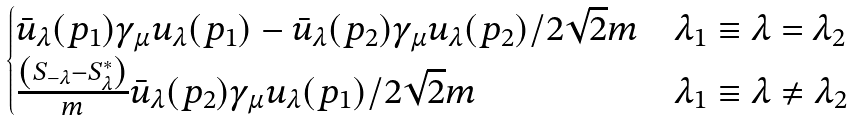<formula> <loc_0><loc_0><loc_500><loc_500>\begin{cases} \bar { u } _ { \lambda } ( p _ { 1 } ) \gamma _ { \mu } u _ { \lambda } ( p _ { 1 } ) - \bar { u } _ { \lambda } ( p _ { 2 } ) \gamma _ { \mu } u _ { \lambda } ( p _ { 2 } ) / 2 \sqrt { 2 } m & \lambda _ { 1 } \equiv \lambda = \lambda _ { 2 } \\ \frac { \left ( S _ { - \lambda } - S ^ { * } _ { \lambda } \right ) } { m } \bar { u } _ { \lambda } ( p _ { 2 } ) \gamma _ { \mu } u _ { \lambda } ( p _ { 1 } ) / 2 \sqrt { 2 } m & \lambda _ { 1 } \equiv \lambda \ne \lambda _ { 2 } \end{cases}</formula> 